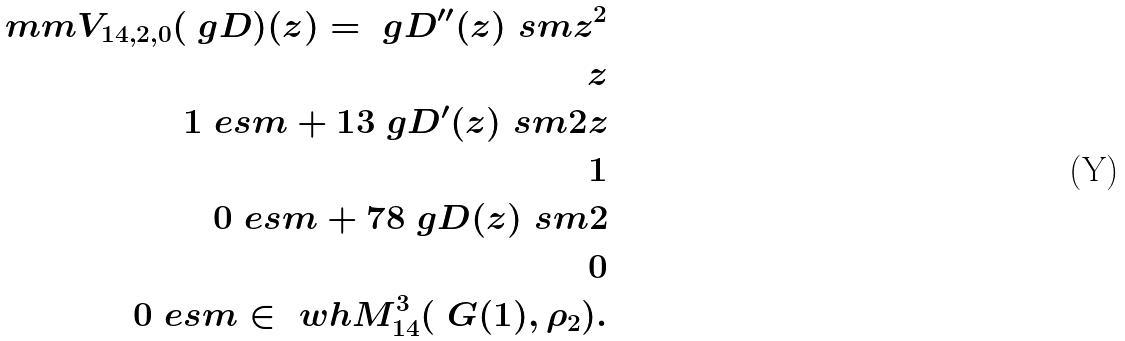<formula> <loc_0><loc_0><loc_500><loc_500>\ m m V _ { 1 4 , 2 , 0 } ( \ g D ) ( z ) = \ g D ^ { \prime \prime } ( z ) \ s m z ^ { 2 } \\ z \\ 1 \ e s m + 1 3 \ g D ^ { \prime } ( z ) \ s m 2 z \\ 1 \\ 0 \ e s m + 7 8 \ g D ( z ) \ s m 2 \\ 0 \\ 0 \ e s m \in \ w h { M } _ { 1 4 } ^ { 3 } ( \ G ( 1 ) , \rho _ { 2 } ) .</formula> 